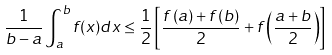Convert formula to latex. <formula><loc_0><loc_0><loc_500><loc_500>\frac { 1 } { b - a } \int _ { a } ^ { b } f ( x ) d x \leq \frac { 1 } { 2 } \left [ \frac { f \left ( a \right ) + f \left ( b \right ) } { 2 } + f \left ( \frac { a + b } { 2 } \right ) \right ]</formula> 